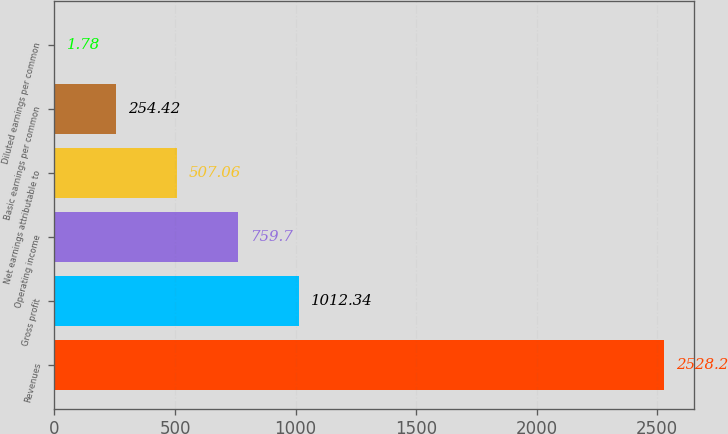Convert chart to OTSL. <chart><loc_0><loc_0><loc_500><loc_500><bar_chart><fcel>Revenues<fcel>Gross profit<fcel>Operating income<fcel>Net earnings attributable to<fcel>Basic earnings per common<fcel>Diluted earnings per common<nl><fcel>2528.2<fcel>1012.34<fcel>759.7<fcel>507.06<fcel>254.42<fcel>1.78<nl></chart> 